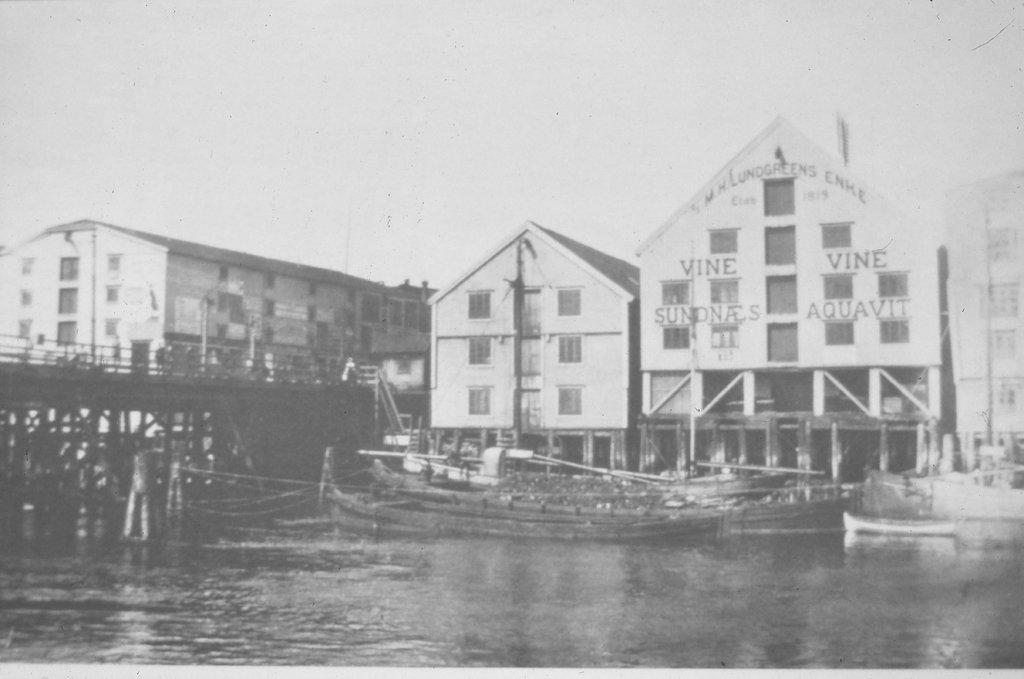How would you summarize this image in a sentence or two? This is black and white picture where we can see so many buildings. In front of the building lake is there and boats are present. To the left side of the image one bridge is there. 